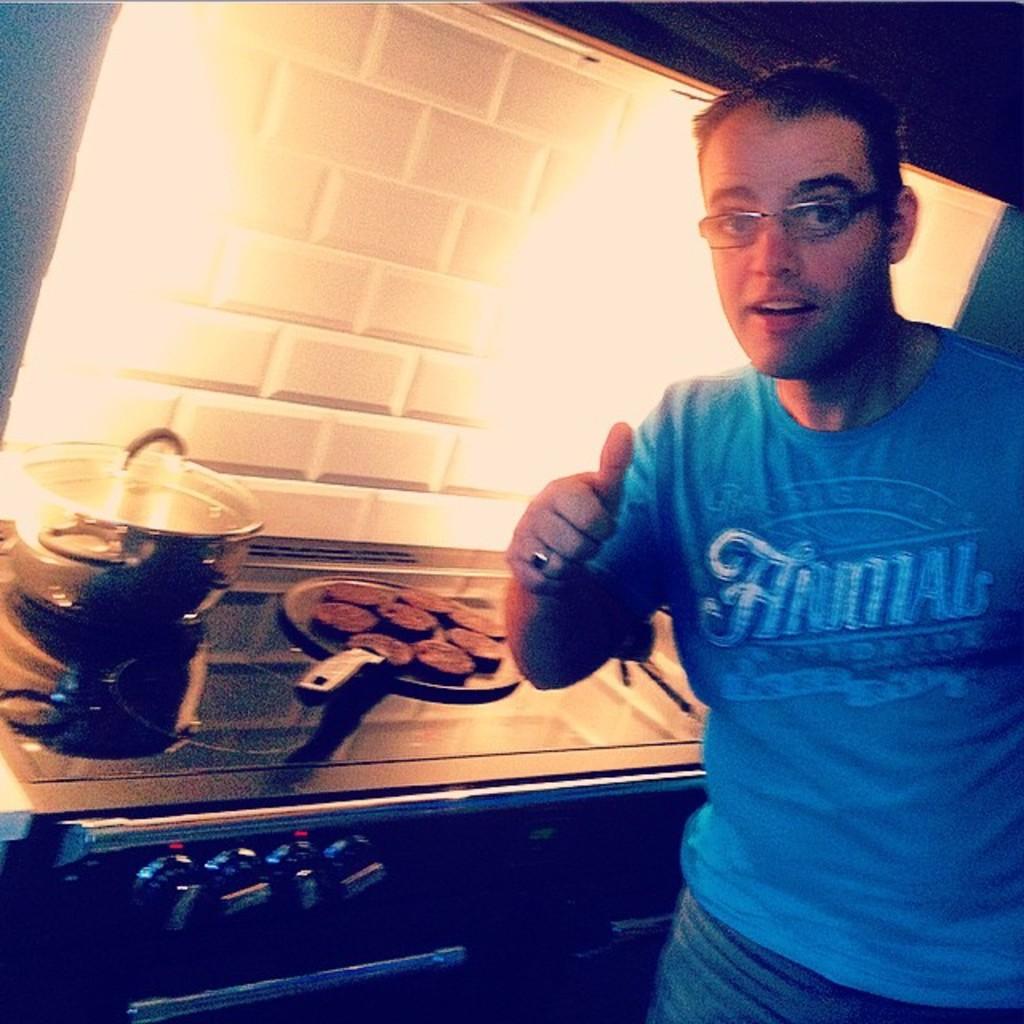What is the mans shirt supporting?
Give a very brief answer. Animal. Is the name on the shirt a reptile?
Provide a short and direct response. No. 